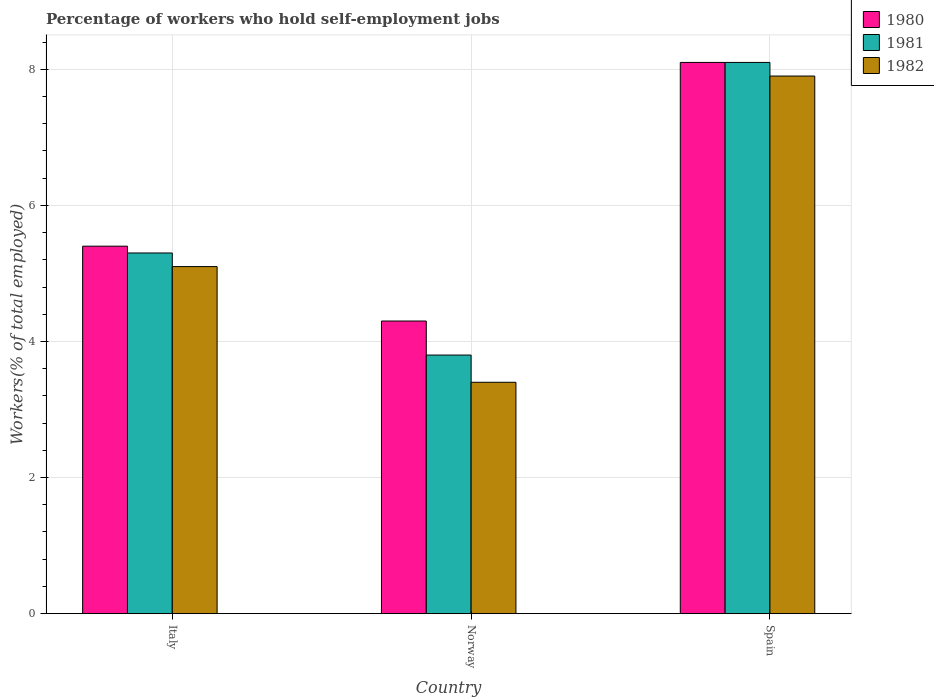How many different coloured bars are there?
Give a very brief answer. 3. Are the number of bars per tick equal to the number of legend labels?
Your answer should be very brief. Yes. How many bars are there on the 2nd tick from the left?
Offer a terse response. 3. How many bars are there on the 3rd tick from the right?
Your answer should be very brief. 3. In how many cases, is the number of bars for a given country not equal to the number of legend labels?
Give a very brief answer. 0. What is the percentage of self-employed workers in 1980 in Italy?
Provide a succinct answer. 5.4. Across all countries, what is the maximum percentage of self-employed workers in 1980?
Your answer should be compact. 8.1. Across all countries, what is the minimum percentage of self-employed workers in 1980?
Ensure brevity in your answer.  4.3. In which country was the percentage of self-employed workers in 1981 maximum?
Ensure brevity in your answer.  Spain. What is the total percentage of self-employed workers in 1982 in the graph?
Offer a very short reply. 16.4. What is the difference between the percentage of self-employed workers in 1981 in Norway and that in Spain?
Provide a succinct answer. -4.3. What is the difference between the percentage of self-employed workers in 1982 in Norway and the percentage of self-employed workers in 1980 in Italy?
Provide a short and direct response. -2. What is the average percentage of self-employed workers in 1980 per country?
Provide a short and direct response. 5.93. What is the difference between the percentage of self-employed workers of/in 1980 and percentage of self-employed workers of/in 1981 in Norway?
Give a very brief answer. 0.5. In how many countries, is the percentage of self-employed workers in 1982 greater than 6.4 %?
Provide a short and direct response. 1. What is the ratio of the percentage of self-employed workers in 1981 in Italy to that in Spain?
Give a very brief answer. 0.65. What is the difference between the highest and the second highest percentage of self-employed workers in 1981?
Your answer should be very brief. 4.3. What is the difference between the highest and the lowest percentage of self-employed workers in 1982?
Your answer should be very brief. 4.5. In how many countries, is the percentage of self-employed workers in 1980 greater than the average percentage of self-employed workers in 1980 taken over all countries?
Provide a short and direct response. 1. What does the 1st bar from the left in Italy represents?
Ensure brevity in your answer.  1980. What does the 3rd bar from the right in Italy represents?
Provide a short and direct response. 1980. How many bars are there?
Offer a terse response. 9. Are all the bars in the graph horizontal?
Your answer should be very brief. No. Are the values on the major ticks of Y-axis written in scientific E-notation?
Make the answer very short. No. Does the graph contain any zero values?
Ensure brevity in your answer.  No. Does the graph contain grids?
Offer a very short reply. Yes. Where does the legend appear in the graph?
Your answer should be very brief. Top right. How are the legend labels stacked?
Offer a terse response. Vertical. What is the title of the graph?
Your answer should be compact. Percentage of workers who hold self-employment jobs. Does "1984" appear as one of the legend labels in the graph?
Make the answer very short. No. What is the label or title of the Y-axis?
Offer a very short reply. Workers(% of total employed). What is the Workers(% of total employed) of 1980 in Italy?
Your response must be concise. 5.4. What is the Workers(% of total employed) of 1981 in Italy?
Your answer should be very brief. 5.3. What is the Workers(% of total employed) in 1982 in Italy?
Your answer should be very brief. 5.1. What is the Workers(% of total employed) of 1980 in Norway?
Offer a very short reply. 4.3. What is the Workers(% of total employed) of 1981 in Norway?
Your response must be concise. 3.8. What is the Workers(% of total employed) in 1982 in Norway?
Give a very brief answer. 3.4. What is the Workers(% of total employed) in 1980 in Spain?
Offer a terse response. 8.1. What is the Workers(% of total employed) in 1981 in Spain?
Your answer should be very brief. 8.1. What is the Workers(% of total employed) in 1982 in Spain?
Keep it short and to the point. 7.9. Across all countries, what is the maximum Workers(% of total employed) of 1980?
Keep it short and to the point. 8.1. Across all countries, what is the maximum Workers(% of total employed) of 1981?
Ensure brevity in your answer.  8.1. Across all countries, what is the maximum Workers(% of total employed) in 1982?
Offer a very short reply. 7.9. Across all countries, what is the minimum Workers(% of total employed) in 1980?
Provide a short and direct response. 4.3. Across all countries, what is the minimum Workers(% of total employed) in 1981?
Your answer should be compact. 3.8. Across all countries, what is the minimum Workers(% of total employed) of 1982?
Provide a succinct answer. 3.4. What is the total Workers(% of total employed) of 1980 in the graph?
Offer a terse response. 17.8. What is the difference between the Workers(% of total employed) in 1981 in Italy and that in Norway?
Give a very brief answer. 1.5. What is the difference between the Workers(% of total employed) of 1980 in Italy and that in Spain?
Your response must be concise. -2.7. What is the difference between the Workers(% of total employed) of 1982 in Italy and that in Spain?
Your response must be concise. -2.8. What is the difference between the Workers(% of total employed) of 1980 in Norway and that in Spain?
Your answer should be compact. -3.8. What is the difference between the Workers(% of total employed) in 1981 in Norway and that in Spain?
Ensure brevity in your answer.  -4.3. What is the difference between the Workers(% of total employed) of 1980 in Italy and the Workers(% of total employed) of 1982 in Norway?
Keep it short and to the point. 2. What is the difference between the Workers(% of total employed) of 1981 in Italy and the Workers(% of total employed) of 1982 in Norway?
Your response must be concise. 1.9. What is the difference between the Workers(% of total employed) of 1981 in Italy and the Workers(% of total employed) of 1982 in Spain?
Keep it short and to the point. -2.6. What is the difference between the Workers(% of total employed) in 1980 in Norway and the Workers(% of total employed) in 1981 in Spain?
Provide a succinct answer. -3.8. What is the difference between the Workers(% of total employed) of 1980 in Norway and the Workers(% of total employed) of 1982 in Spain?
Your response must be concise. -3.6. What is the difference between the Workers(% of total employed) of 1981 in Norway and the Workers(% of total employed) of 1982 in Spain?
Make the answer very short. -4.1. What is the average Workers(% of total employed) in 1980 per country?
Your answer should be very brief. 5.93. What is the average Workers(% of total employed) of 1981 per country?
Your response must be concise. 5.73. What is the average Workers(% of total employed) of 1982 per country?
Make the answer very short. 5.47. What is the difference between the Workers(% of total employed) in 1980 and Workers(% of total employed) in 1982 in Italy?
Offer a terse response. 0.3. What is the difference between the Workers(% of total employed) in 1980 and Workers(% of total employed) in 1981 in Spain?
Your response must be concise. 0. What is the difference between the Workers(% of total employed) of 1980 and Workers(% of total employed) of 1982 in Spain?
Your response must be concise. 0.2. What is the ratio of the Workers(% of total employed) of 1980 in Italy to that in Norway?
Provide a short and direct response. 1.26. What is the ratio of the Workers(% of total employed) of 1981 in Italy to that in Norway?
Provide a short and direct response. 1.39. What is the ratio of the Workers(% of total employed) in 1980 in Italy to that in Spain?
Provide a short and direct response. 0.67. What is the ratio of the Workers(% of total employed) in 1981 in Italy to that in Spain?
Ensure brevity in your answer.  0.65. What is the ratio of the Workers(% of total employed) of 1982 in Italy to that in Spain?
Give a very brief answer. 0.65. What is the ratio of the Workers(% of total employed) in 1980 in Norway to that in Spain?
Keep it short and to the point. 0.53. What is the ratio of the Workers(% of total employed) in 1981 in Norway to that in Spain?
Give a very brief answer. 0.47. What is the ratio of the Workers(% of total employed) of 1982 in Norway to that in Spain?
Offer a terse response. 0.43. What is the difference between the highest and the second highest Workers(% of total employed) of 1980?
Provide a short and direct response. 2.7. What is the difference between the highest and the second highest Workers(% of total employed) in 1981?
Give a very brief answer. 2.8. What is the difference between the highest and the lowest Workers(% of total employed) of 1981?
Ensure brevity in your answer.  4.3. 